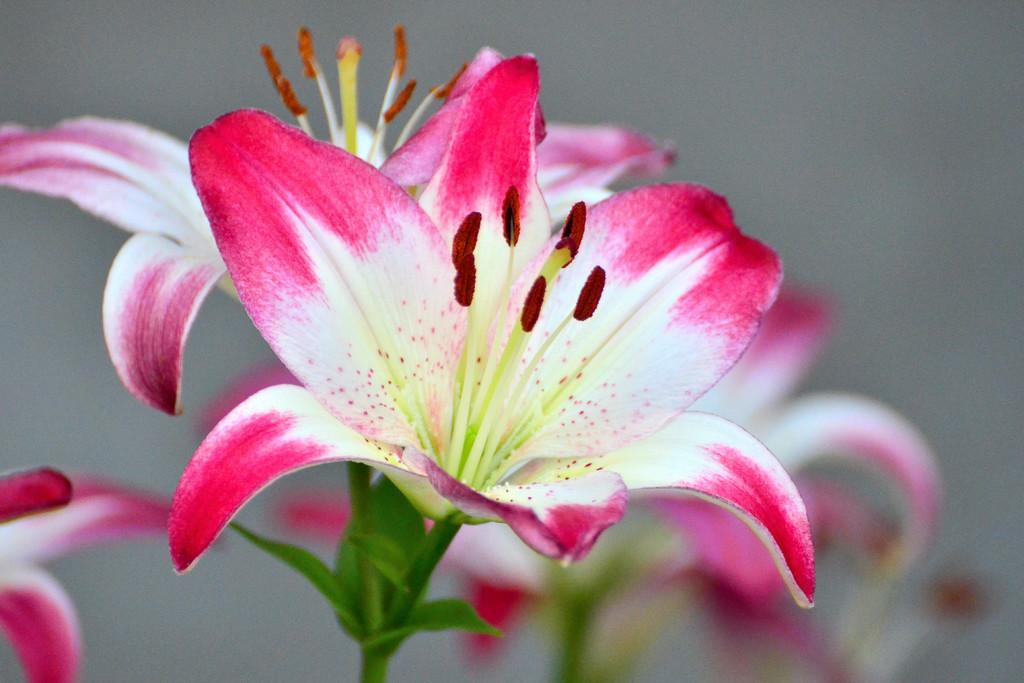What type of plants can be seen in the image? There are flowers and leaves in the image. Can you describe the background of the image? The background of the image is blurry. What type of knot is being tied by the army in the image? There is no army or knot present in the image; it features flowers and leaves with a blurry background. 